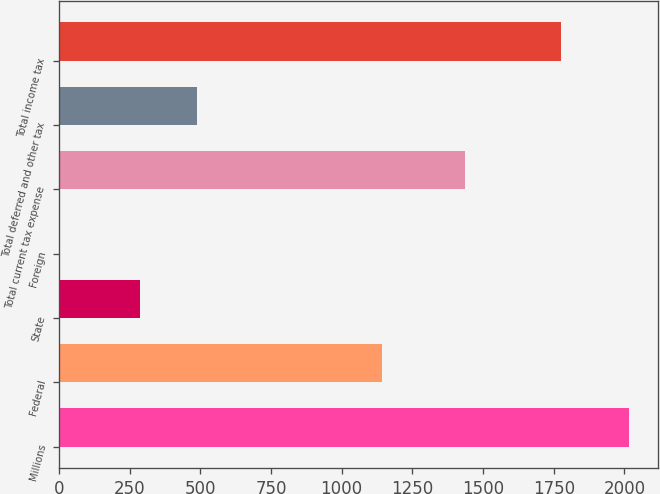Convert chart to OTSL. <chart><loc_0><loc_0><loc_500><loc_500><bar_chart><fcel>Millions<fcel>Federal<fcel>State<fcel>Foreign<fcel>Total current tax expense<fcel>Total deferred and other tax<fcel>Total income tax<nl><fcel>2018<fcel>1144<fcel>287<fcel>5<fcel>1436<fcel>488.3<fcel>1775<nl></chart> 